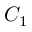<formula> <loc_0><loc_0><loc_500><loc_500>C _ { 1 }</formula> 